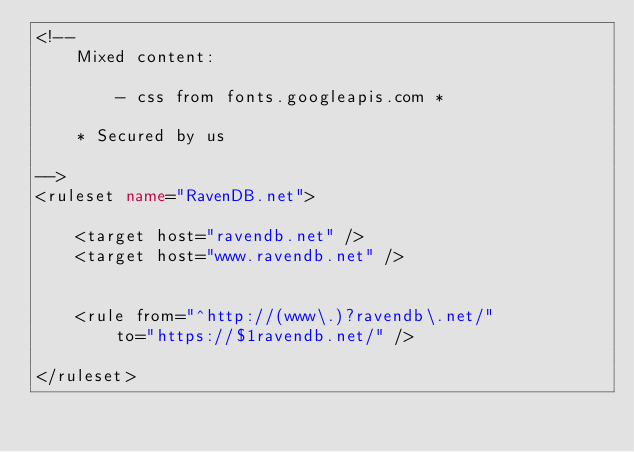<code> <loc_0><loc_0><loc_500><loc_500><_XML_><!--
	Mixed content:

		- css from fonts.googleapis.com *

	* Secured by us

-->
<ruleset name="RavenDB.net">

	<target host="ravendb.net" />
	<target host="www.ravendb.net" />


	<rule from="^http://(www\.)?ravendb\.net/"
		to="https://$1ravendb.net/" />

</ruleset>
</code> 